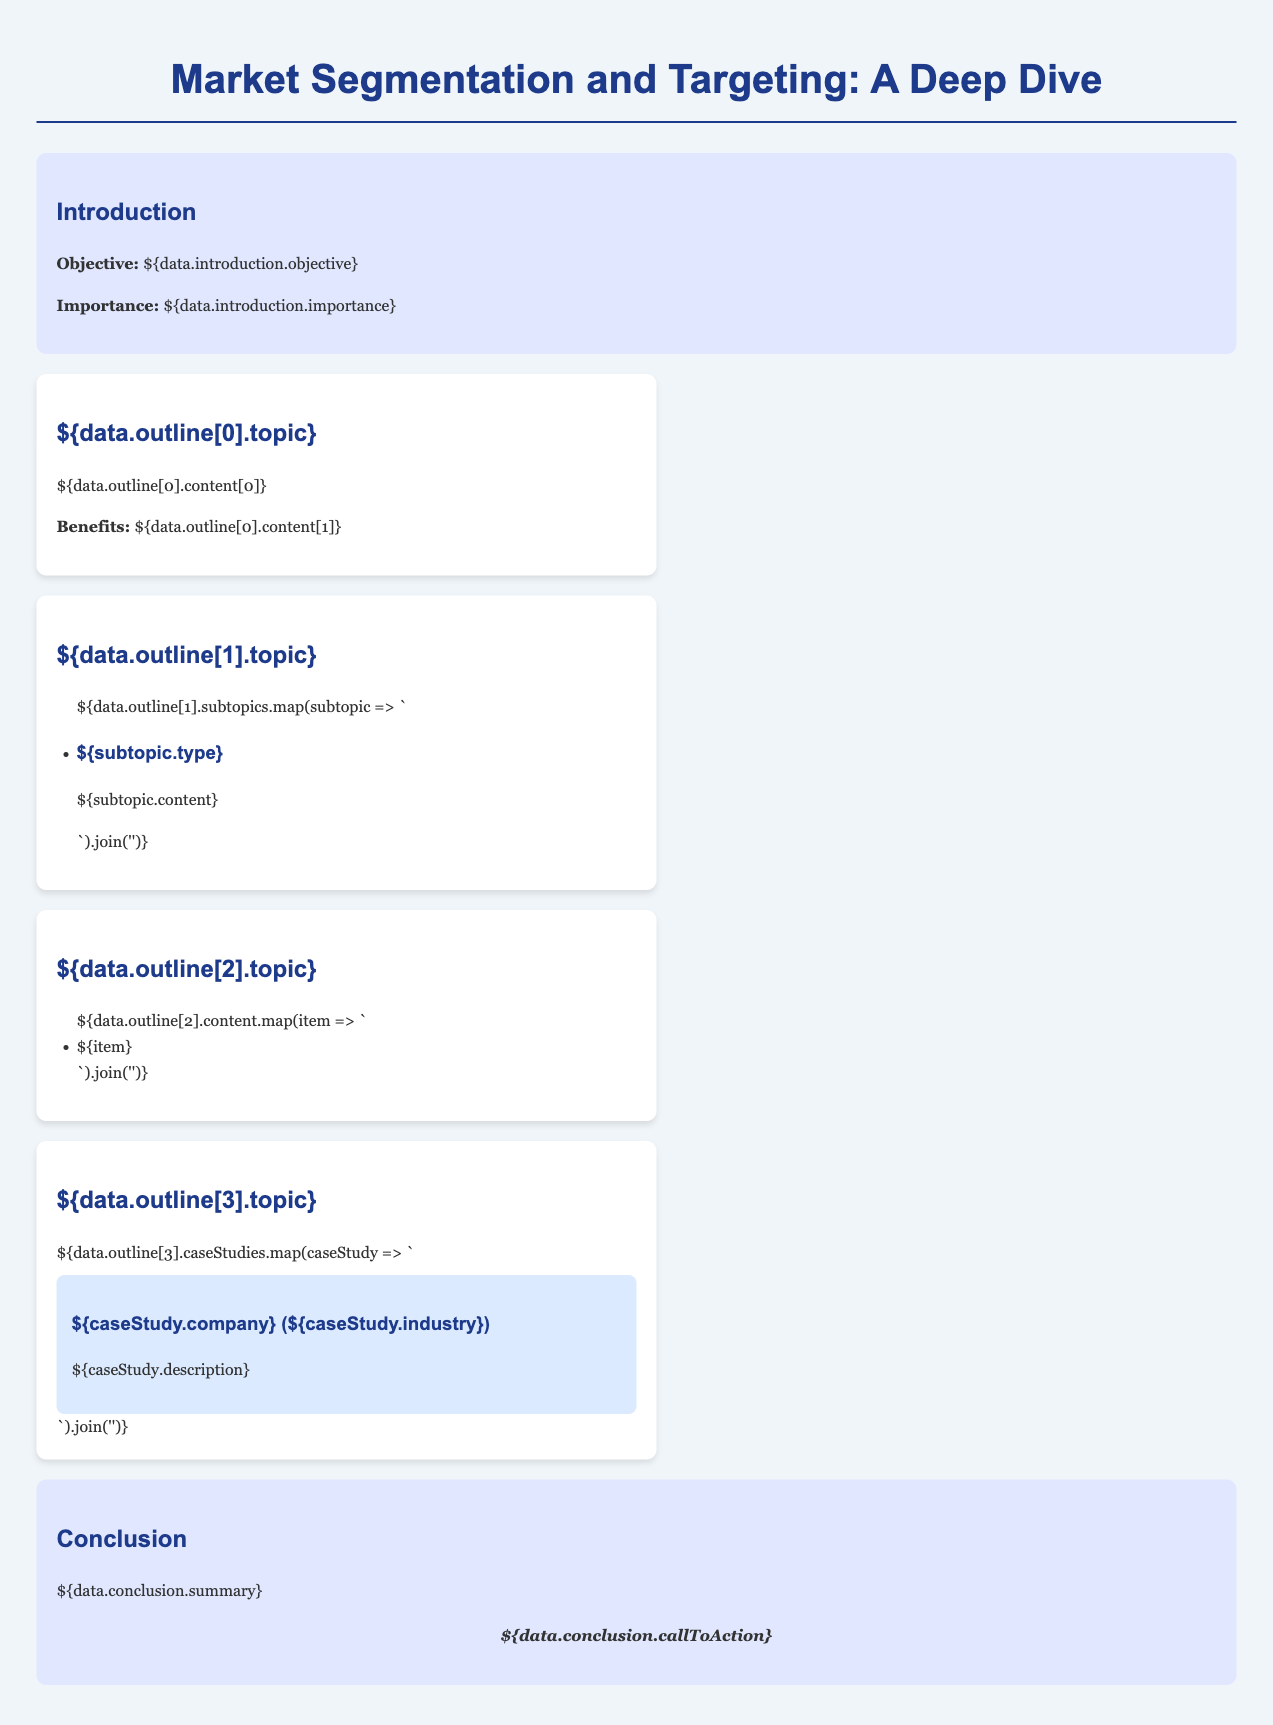What is the lesson title? The lesson title is prominently displayed at the top of the document, making it clear and easy to find.
Answer: Market Segmentation and Targeting: A Deep Dive What are the types of segmentation mentioned? The document lists and describes different types of segmentation as part of the outline.
Answer: Geographic, demographic, psychographic, behavioral What industry is used as a case study for Netflix? The document highlights specific companies and their industries in the case studies section.
Answer: Entertainment What is the objective of the lesson? The objective is stated in the introduction section, reflecting the purpose of the lesson.
Answer: Understanding market segmentation and its importance Which topic discusses tailoring marketing strategies? The topics in the outline cover various aspects of market segmentation and targeting clearly.
Answer: Tailoring Marketing Strategies What is the call to action in the conclusion? The call to action is provided in the conclusion, encouraging further engagement or thought on the topic.
Answer: Explore different market segments further! 